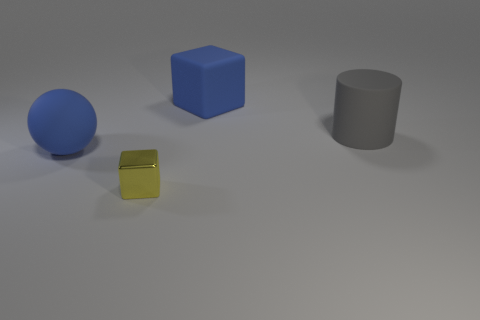Add 4 tiny yellow objects. How many objects exist? 8 Subtract all yellow cubes. How many cubes are left? 1 Subtract all spheres. How many objects are left? 3 Subtract all yellow balls. Subtract all blue cylinders. How many balls are left? 1 Subtract all green cylinders. How many brown blocks are left? 0 Subtract all tiny brown rubber balls. Subtract all blue rubber blocks. How many objects are left? 3 Add 3 gray cylinders. How many gray cylinders are left? 4 Add 1 large matte balls. How many large matte balls exist? 2 Subtract 1 gray cylinders. How many objects are left? 3 